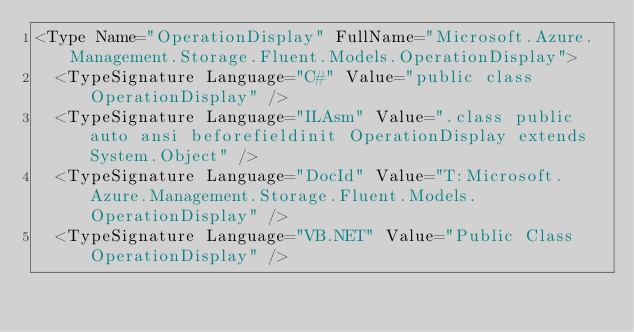Convert code to text. <code><loc_0><loc_0><loc_500><loc_500><_XML_><Type Name="OperationDisplay" FullName="Microsoft.Azure.Management.Storage.Fluent.Models.OperationDisplay">
  <TypeSignature Language="C#" Value="public class OperationDisplay" />
  <TypeSignature Language="ILAsm" Value=".class public auto ansi beforefieldinit OperationDisplay extends System.Object" />
  <TypeSignature Language="DocId" Value="T:Microsoft.Azure.Management.Storage.Fluent.Models.OperationDisplay" />
  <TypeSignature Language="VB.NET" Value="Public Class OperationDisplay" /></code> 